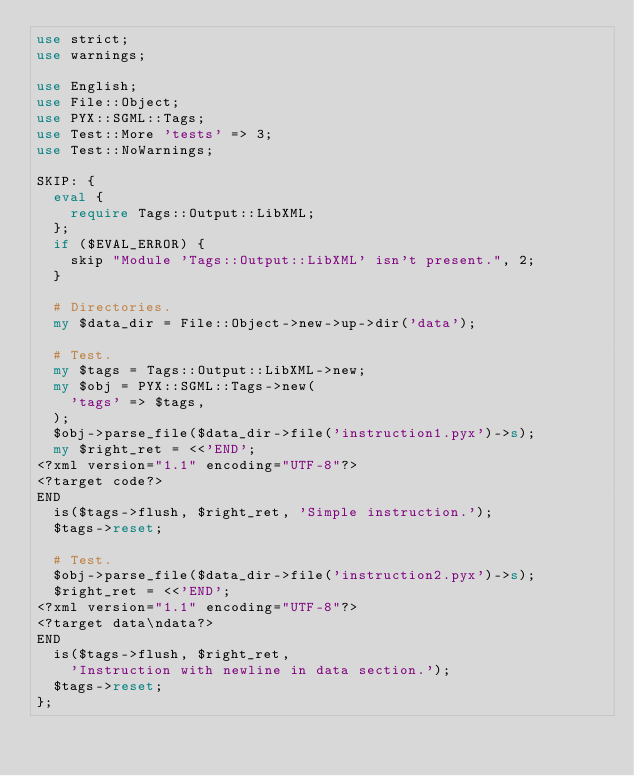Convert code to text. <code><loc_0><loc_0><loc_500><loc_500><_Perl_>use strict;
use warnings;

use English;
use File::Object;
use PYX::SGML::Tags;
use Test::More 'tests' => 3;
use Test::NoWarnings;

SKIP: {
	eval {
		require Tags::Output::LibXML;
	};
	if ($EVAL_ERROR) {
		skip "Module 'Tags::Output::LibXML' isn't present.", 2;
	}

	# Directories.
	my $data_dir = File::Object->new->up->dir('data');

	# Test.
	my $tags = Tags::Output::LibXML->new;
	my $obj = PYX::SGML::Tags->new(
		'tags' => $tags,
	);
	$obj->parse_file($data_dir->file('instruction1.pyx')->s);
	my $right_ret = <<'END';
<?xml version="1.1" encoding="UTF-8"?>
<?target code?>
END
	is($tags->flush, $right_ret, 'Simple instruction.');
	$tags->reset;

	# Test.
	$obj->parse_file($data_dir->file('instruction2.pyx')->s);
	$right_ret = <<'END';
<?xml version="1.1" encoding="UTF-8"?>
<?target data\ndata?>
END
	is($tags->flush, $right_ret,
		'Instruction with newline in data section.');
	$tags->reset;
};
</code> 